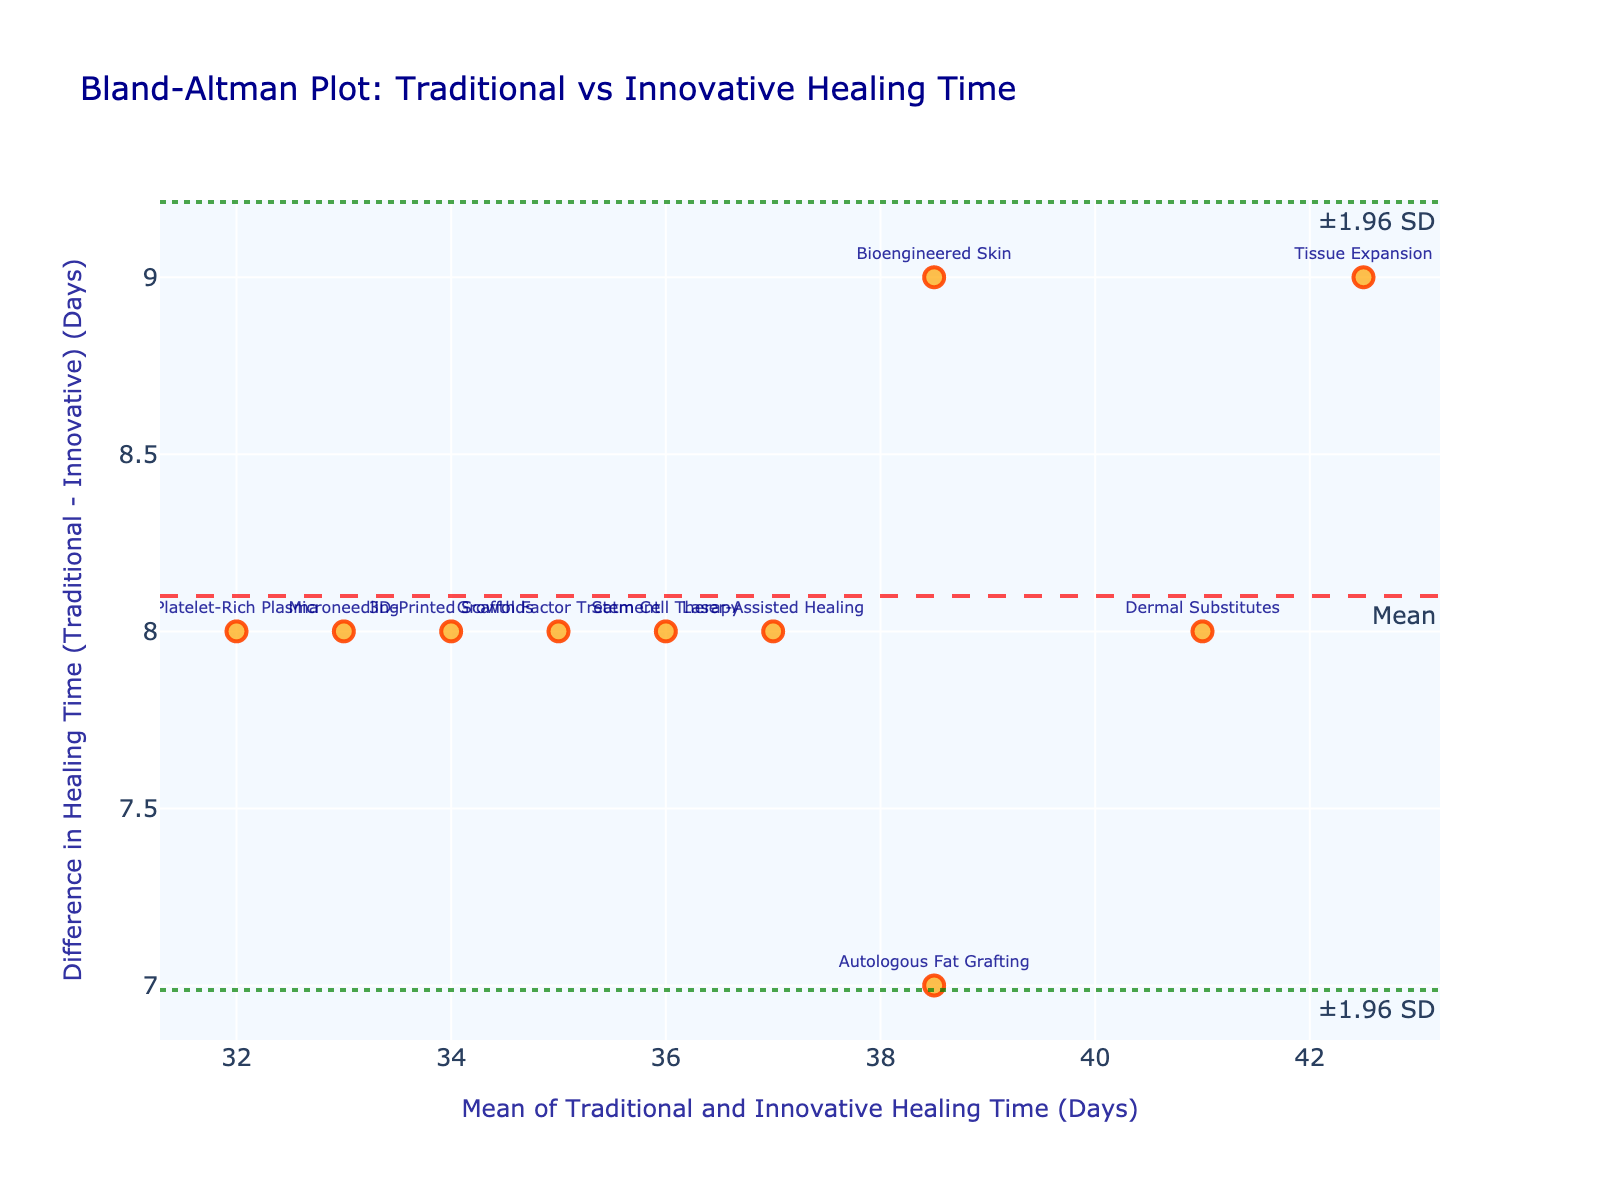What is the title of the plot? The title of the plot is displayed at the top in a larger font and typically stands out from the rest of the text within the figure's layout.
Answer: Bland-Altman Plot: Traditional vs Innovative Healing Time How many data points are there in the plot? The number of data points is indicated by the number of markers (or dots) present in the scatter plot within the figure. Each marker represents a unique method of facial reconstruction.
Answer: 10 Which method shows the largest positive difference in healing time between Traditional and Innovative approaches? To find this, locate the marker that is highest above the zero line on the vertical axis, which represents the greatest positive difference. The annotation text associated with that marker indicates the method.
Answer: Tissue Expansion What are the limits of agreement in the plot? The limits of agreement are indicated by the two dotted horizontal lines. These lines mark the range within which most differences between the methods lie (±1.96 SD from the mean difference).
Answer: approximately (3.1, 12.3) days Which method has the smallest difference in healing time between Traditional and Innovative approaches? Locate the marker closest to the horizontal axis at y=0, and check the annotation text for that marker.
Answer: 3D-Printed Scaffolds What is the range of the differences in healing times for the methods? To determine the range, identify the highest and lowest markers on the vertical axis and calculate the difference between them.
Answer: Range is between -1 and 9 days Which method shows an equal difference and mean in healing times? To answer this compositional question, find the marker positioned where its vertical distance is equal to its horizontal distance from the origin.
Answer: Bioengineered Skin How is scar formation compared in traditional vs innovative methods for the method closest to the mean difference? From the plot, identify which method is closest to the mean difference line, and then refer to the provided data to compare scar formation for that method. The method closest to the mean is "Stem Cell Therapy," with healing times of 40 days (traditional) and 32 days (innovative). Referring to the data, traditional scar formation is 140 mm² and innovative is 105 mm².
Answer: Traditional: 140 mm², Innovative: 105 mm² Which method has the highest mean healing time for traditional and innovative methods combined? Calculate the means of each method’s healing times (Traditional + Innovative)/2. Identify which method has the highest result.
Answer: Tissue Expansion 